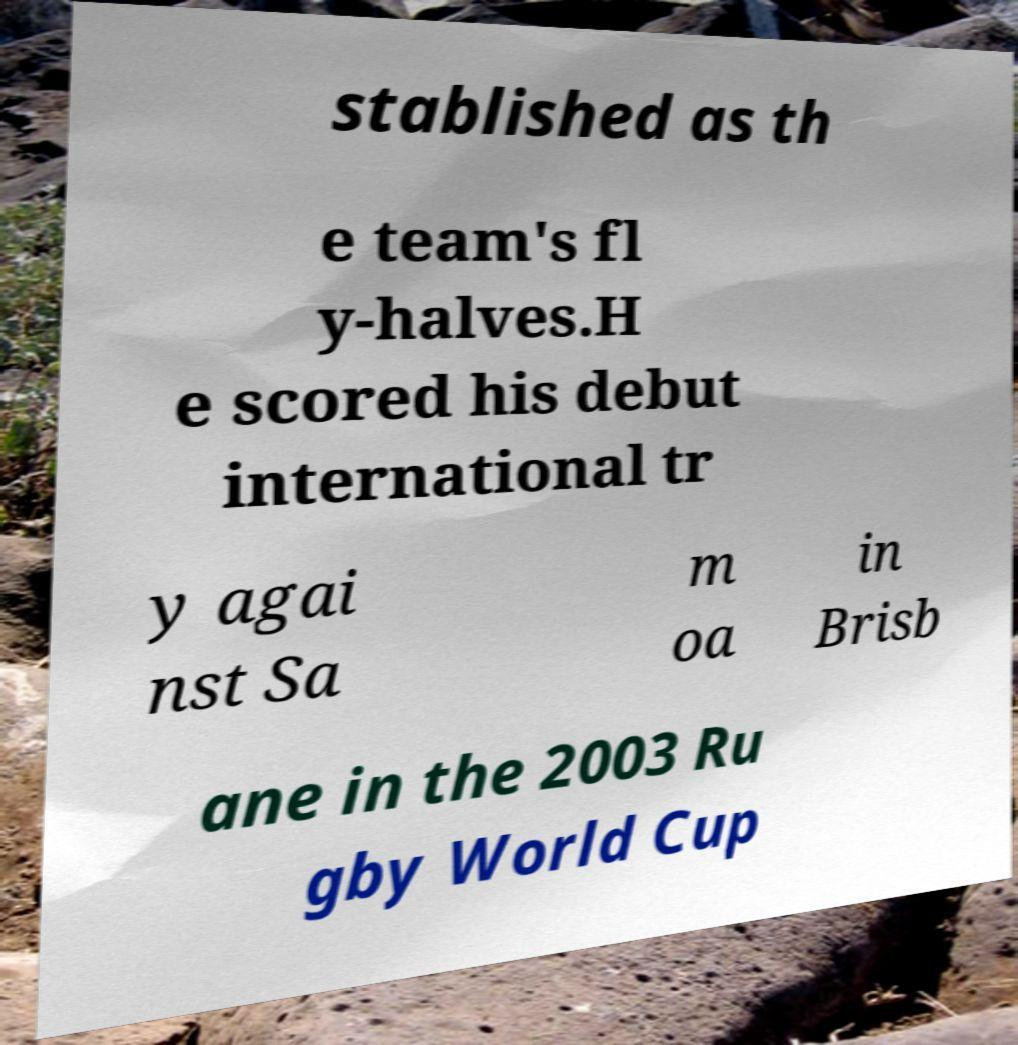Could you extract and type out the text from this image? stablished as th e team's fl y-halves.H e scored his debut international tr y agai nst Sa m oa in Brisb ane in the 2003 Ru gby World Cup 